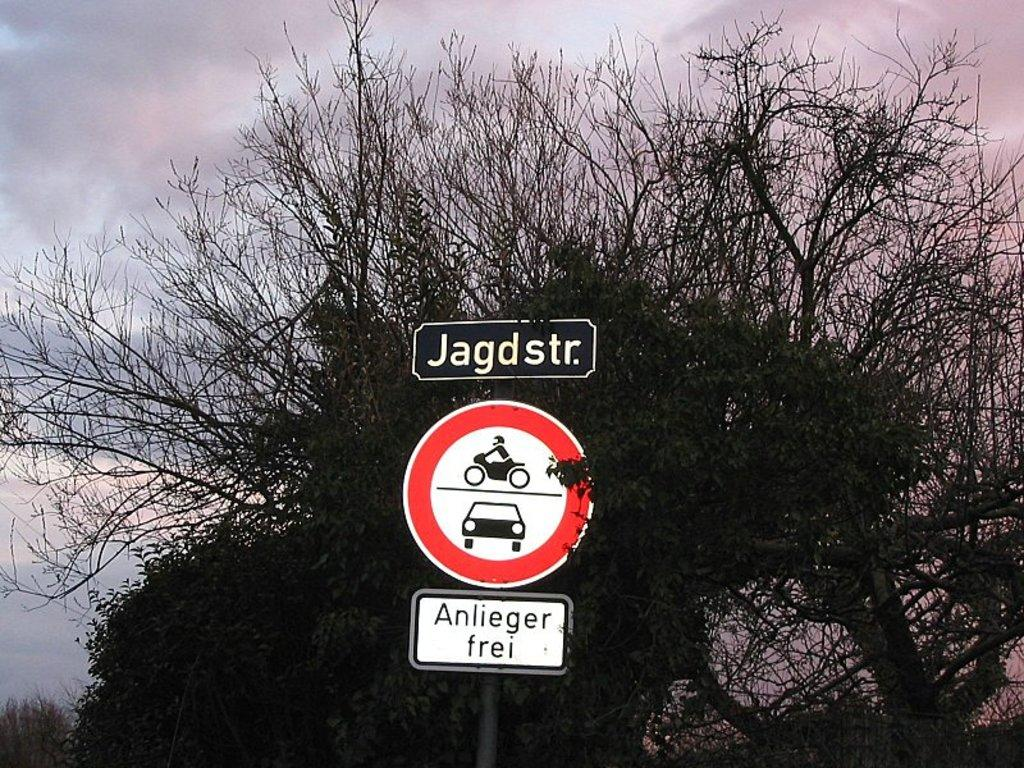What can be seen in the background of the image? There is sky and trees visible in the background of the image. What is present in the foreground of the image? There is a sign board and two other boards on a pole in the image. What type of calendar is hanging from the elbow of the person in the image? There is no person present in the image, and therefore no elbow or calendar can be observed. 